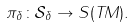Convert formula to latex. <formula><loc_0><loc_0><loc_500><loc_500>\pi _ { \delta } \colon \mathcal { S } _ { \delta } \rightarrow S ( T M ) .</formula> 